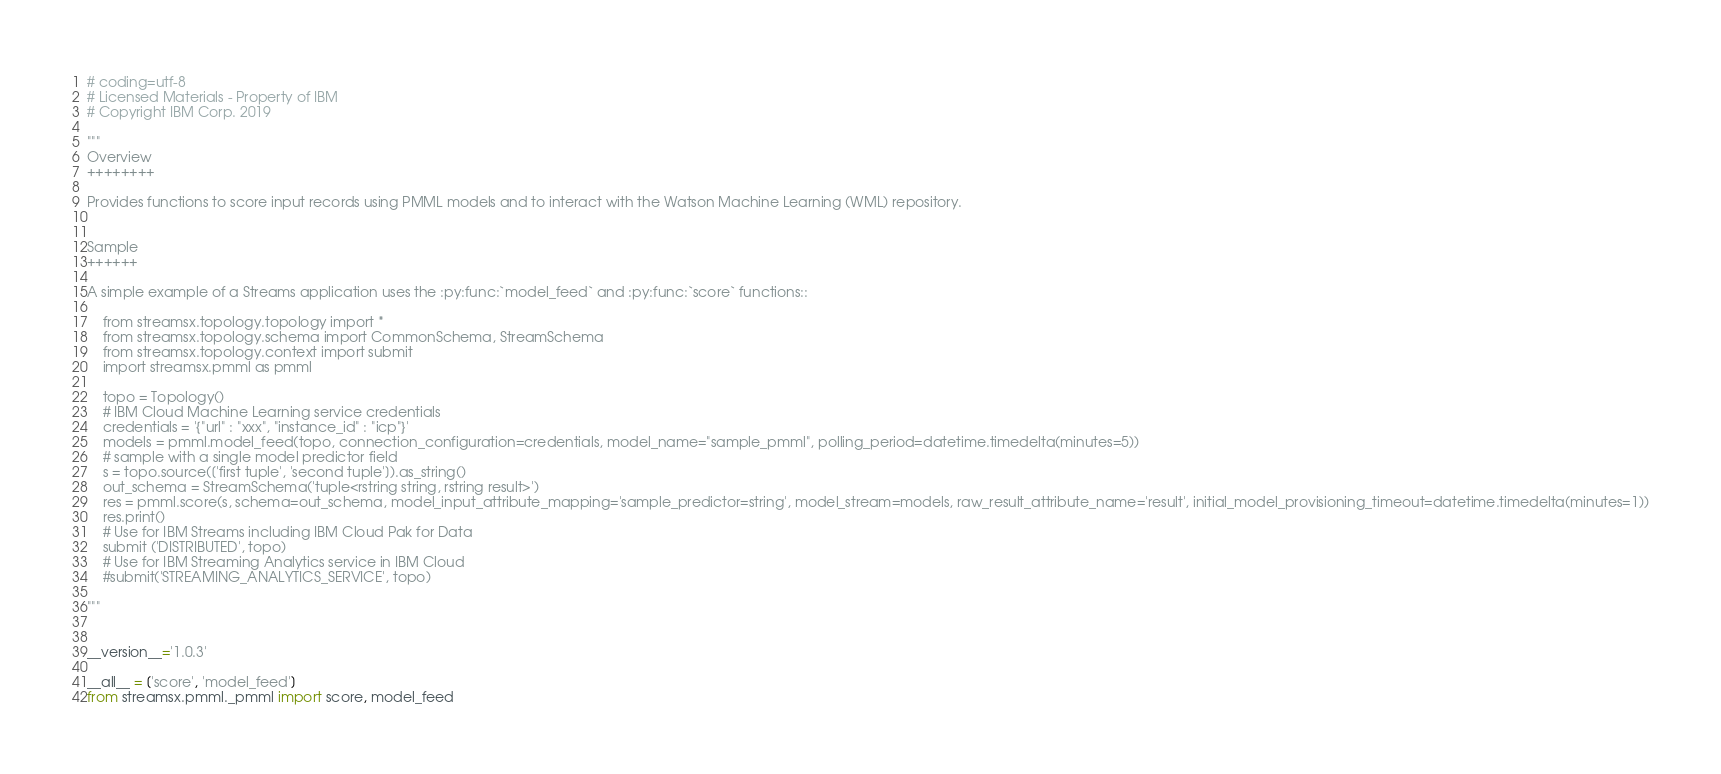Convert code to text. <code><loc_0><loc_0><loc_500><loc_500><_Python_># coding=utf-8
# Licensed Materials - Property of IBM
# Copyright IBM Corp. 2019

"""
Overview
++++++++

Provides functions to score input records using PMML models and to interact with the Watson Machine Learning (WML) repository.


Sample
++++++

A simple example of a Streams application uses the :py:func:`model_feed` and :py:func:`score` functions::

    from streamsx.topology.topology import *
    from streamsx.topology.schema import CommonSchema, StreamSchema
    from streamsx.topology.context import submit
    import streamsx.pmml as pmml

    topo = Topology()
    # IBM Cloud Machine Learning service credentials
    credentials = '{"url" : "xxx", "instance_id" : "icp"}'
    models = pmml.model_feed(topo, connection_configuration=credentials, model_name="sample_pmml", polling_period=datetime.timedelta(minutes=5))
    # sample with a single model predictor field
    s = topo.source(['first tuple', 'second tuple']).as_string()
    out_schema = StreamSchema('tuple<rstring string, rstring result>')
    res = pmml.score(s, schema=out_schema, model_input_attribute_mapping='sample_predictor=string', model_stream=models, raw_result_attribute_name='result', initial_model_provisioning_timeout=datetime.timedelta(minutes=1))
    res.print()
    # Use for IBM Streams including IBM Cloud Pak for Data
    submit ('DISTRIBUTED', topo)
    # Use for IBM Streaming Analytics service in IBM Cloud
    #submit('STREAMING_ANALYTICS_SERVICE', topo)

"""


__version__='1.0.3'

__all__ = ['score', 'model_feed']
from streamsx.pmml._pmml import score, model_feed

</code> 